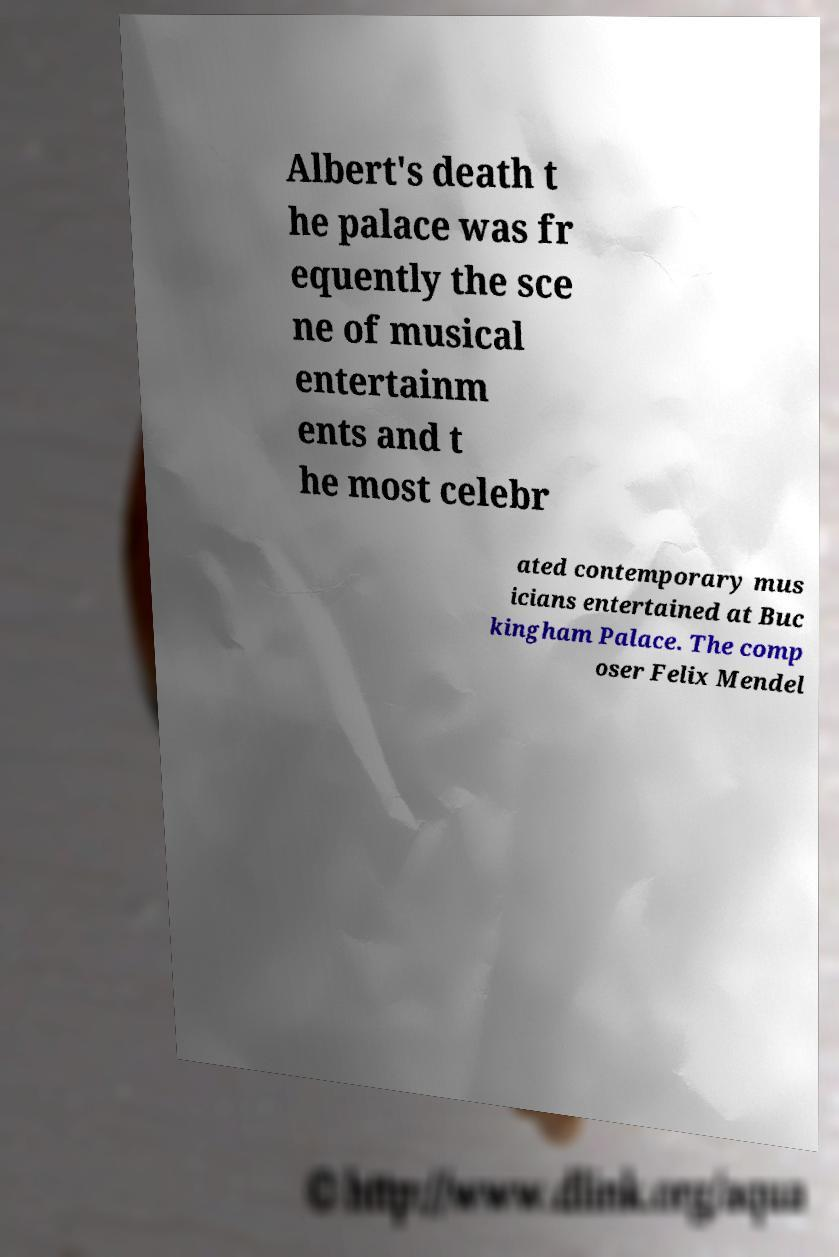Please identify and transcribe the text found in this image. Albert's death t he palace was fr equently the sce ne of musical entertainm ents and t he most celebr ated contemporary mus icians entertained at Buc kingham Palace. The comp oser Felix Mendel 